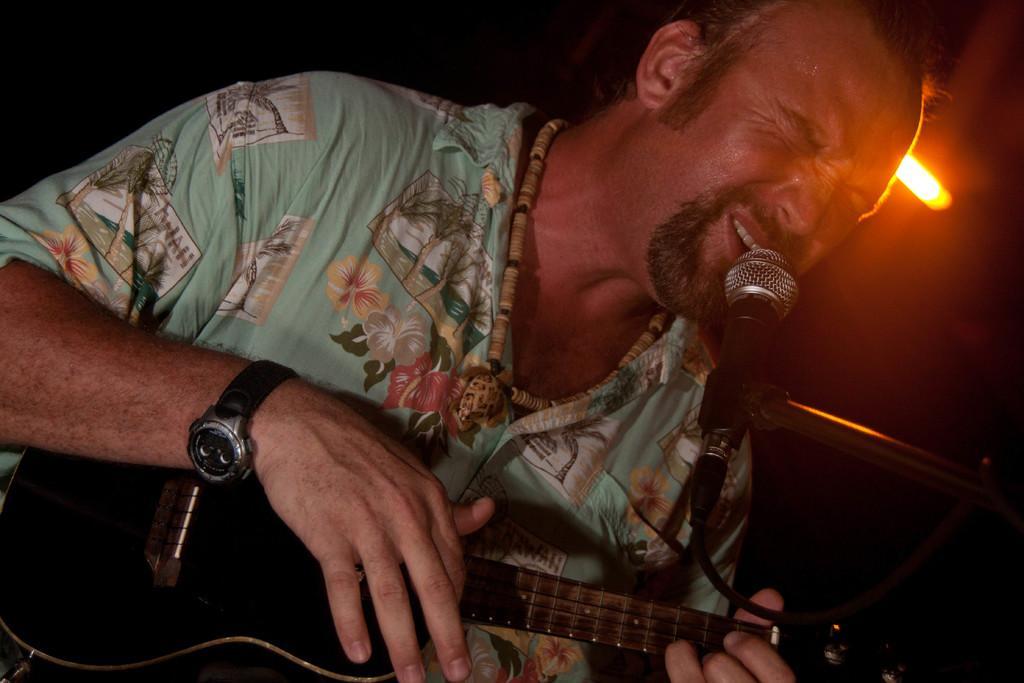How would you summarize this image in a sentence or two? In the image there is a man playing guitar and singing on mic and behind him there is a light. 